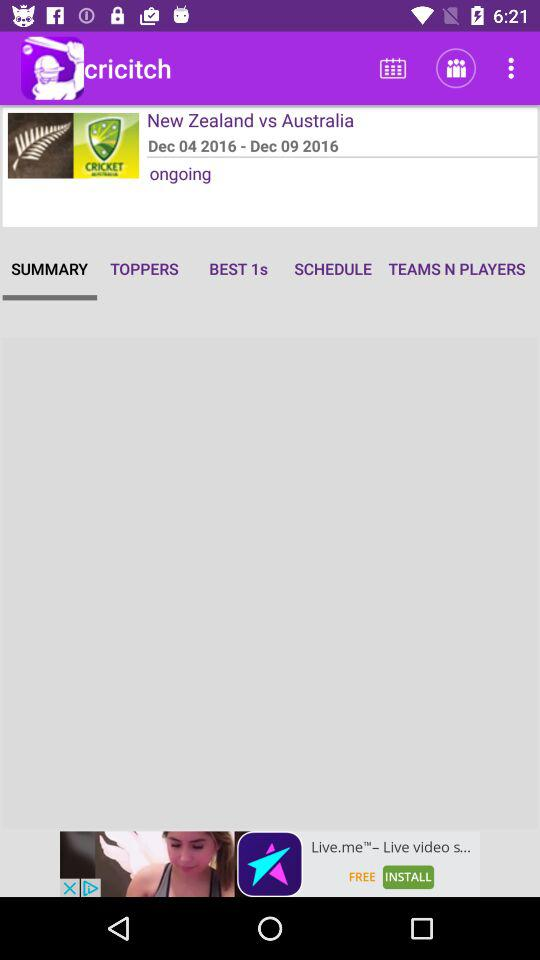What is the end date of the match? The end date of the match is December 9, 2016. 